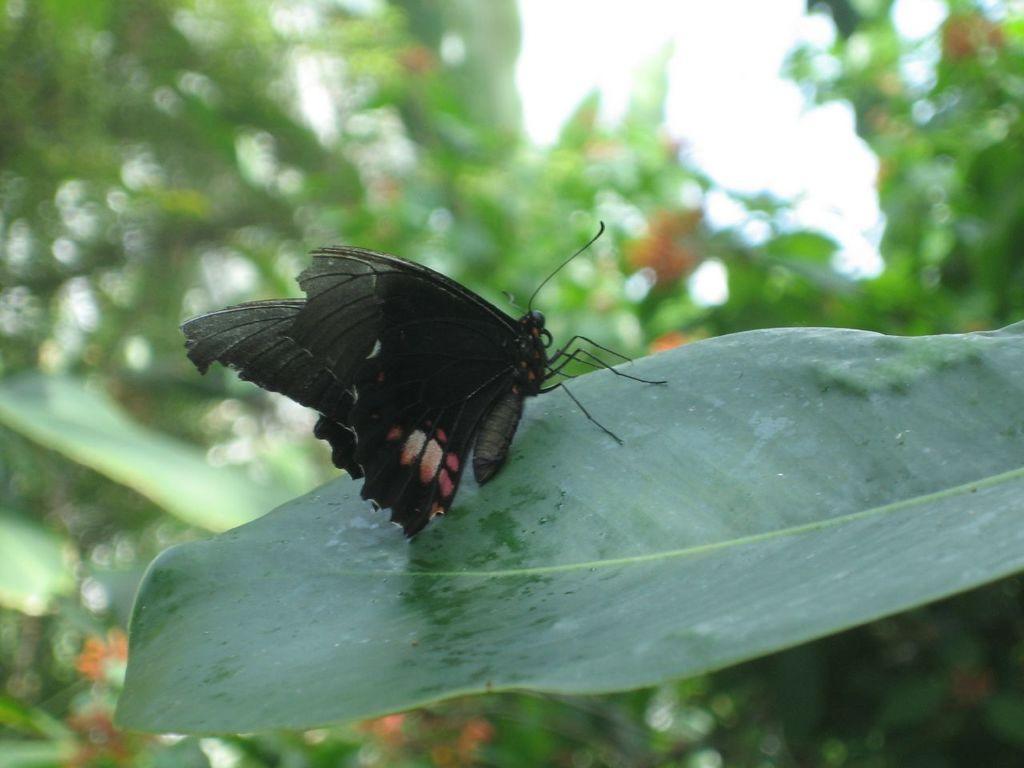Can you describe this image briefly? In this image there is a butterfly on the leaf. In the background of the image there are trees and sky. 